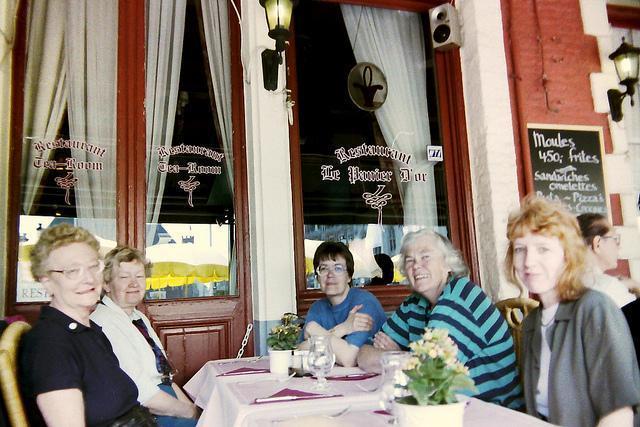How many people are at the table?
Give a very brief answer. 5. How many people can you see?
Give a very brief answer. 6. How many umbrellas are open?
Give a very brief answer. 0. 